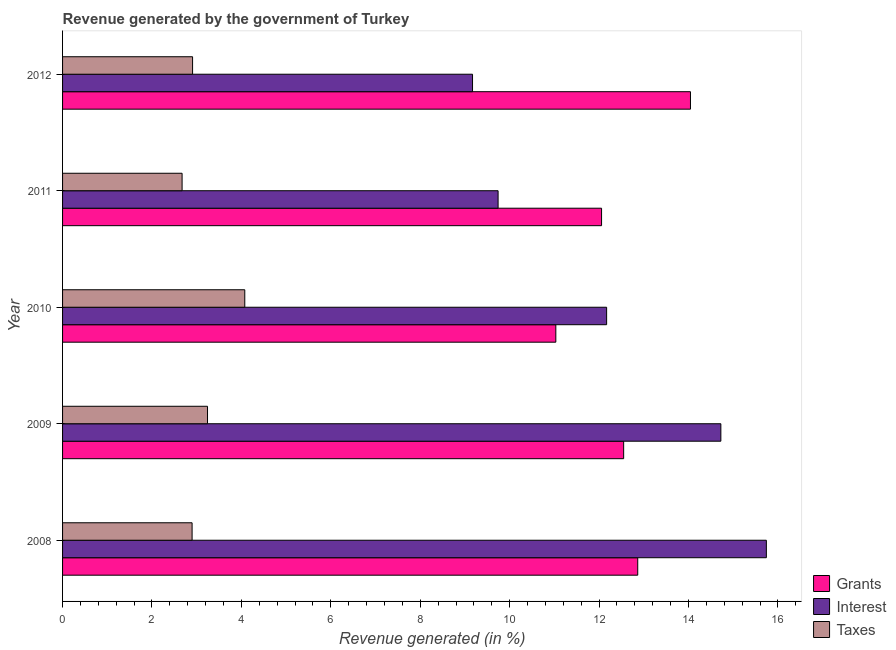How many different coloured bars are there?
Keep it short and to the point. 3. How many groups of bars are there?
Offer a terse response. 5. Are the number of bars per tick equal to the number of legend labels?
Give a very brief answer. Yes. Are the number of bars on each tick of the Y-axis equal?
Your answer should be very brief. Yes. How many bars are there on the 2nd tick from the top?
Make the answer very short. 3. How many bars are there on the 5th tick from the bottom?
Your response must be concise. 3. What is the percentage of revenue generated by grants in 2008?
Your answer should be compact. 12.86. Across all years, what is the maximum percentage of revenue generated by grants?
Offer a terse response. 14.04. Across all years, what is the minimum percentage of revenue generated by grants?
Your answer should be compact. 11.03. What is the total percentage of revenue generated by taxes in the graph?
Provide a succinct answer. 15.8. What is the difference between the percentage of revenue generated by interest in 2008 and that in 2010?
Ensure brevity in your answer.  3.57. What is the difference between the percentage of revenue generated by taxes in 2010 and the percentage of revenue generated by grants in 2012?
Offer a terse response. -9.97. What is the average percentage of revenue generated by grants per year?
Offer a terse response. 12.51. In the year 2010, what is the difference between the percentage of revenue generated by grants and percentage of revenue generated by interest?
Your response must be concise. -1.14. In how many years, is the percentage of revenue generated by taxes greater than 8.4 %?
Keep it short and to the point. 0. What is the ratio of the percentage of revenue generated by grants in 2009 to that in 2011?
Provide a succinct answer. 1.04. Is the percentage of revenue generated by taxes in 2008 less than that in 2012?
Your answer should be compact. Yes. What is the difference between the highest and the second highest percentage of revenue generated by interest?
Your answer should be compact. 1.02. What is the difference between the highest and the lowest percentage of revenue generated by grants?
Offer a terse response. 3.01. In how many years, is the percentage of revenue generated by interest greater than the average percentage of revenue generated by interest taken over all years?
Make the answer very short. 2. Is the sum of the percentage of revenue generated by taxes in 2008 and 2010 greater than the maximum percentage of revenue generated by interest across all years?
Make the answer very short. No. What does the 2nd bar from the top in 2012 represents?
Offer a terse response. Interest. What does the 2nd bar from the bottom in 2011 represents?
Provide a succinct answer. Interest. Is it the case that in every year, the sum of the percentage of revenue generated by grants and percentage of revenue generated by interest is greater than the percentage of revenue generated by taxes?
Provide a succinct answer. Yes. How many bars are there?
Your answer should be very brief. 15. How many years are there in the graph?
Your answer should be compact. 5. Are the values on the major ticks of X-axis written in scientific E-notation?
Your answer should be compact. No. Does the graph contain grids?
Your answer should be compact. No. Where does the legend appear in the graph?
Offer a very short reply. Bottom right. How many legend labels are there?
Your response must be concise. 3. What is the title of the graph?
Your answer should be compact. Revenue generated by the government of Turkey. Does "Food" appear as one of the legend labels in the graph?
Ensure brevity in your answer.  No. What is the label or title of the X-axis?
Offer a terse response. Revenue generated (in %). What is the Revenue generated (in %) of Grants in 2008?
Make the answer very short. 12.86. What is the Revenue generated (in %) in Interest in 2008?
Give a very brief answer. 15.74. What is the Revenue generated (in %) of Taxes in 2008?
Your answer should be very brief. 2.9. What is the Revenue generated (in %) in Grants in 2009?
Give a very brief answer. 12.55. What is the Revenue generated (in %) of Interest in 2009?
Offer a very short reply. 14.72. What is the Revenue generated (in %) of Taxes in 2009?
Your response must be concise. 3.24. What is the Revenue generated (in %) in Grants in 2010?
Your answer should be very brief. 11.03. What is the Revenue generated (in %) in Interest in 2010?
Your answer should be very brief. 12.17. What is the Revenue generated (in %) in Taxes in 2010?
Make the answer very short. 4.08. What is the Revenue generated (in %) of Grants in 2011?
Keep it short and to the point. 12.05. What is the Revenue generated (in %) in Interest in 2011?
Keep it short and to the point. 9.74. What is the Revenue generated (in %) in Taxes in 2011?
Make the answer very short. 2.67. What is the Revenue generated (in %) in Grants in 2012?
Provide a succinct answer. 14.04. What is the Revenue generated (in %) in Interest in 2012?
Provide a short and direct response. 9.17. What is the Revenue generated (in %) of Taxes in 2012?
Offer a very short reply. 2.91. Across all years, what is the maximum Revenue generated (in %) in Grants?
Provide a succinct answer. 14.04. Across all years, what is the maximum Revenue generated (in %) of Interest?
Provide a short and direct response. 15.74. Across all years, what is the maximum Revenue generated (in %) in Taxes?
Your answer should be very brief. 4.08. Across all years, what is the minimum Revenue generated (in %) in Grants?
Offer a terse response. 11.03. Across all years, what is the minimum Revenue generated (in %) of Interest?
Make the answer very short. 9.17. Across all years, what is the minimum Revenue generated (in %) in Taxes?
Your response must be concise. 2.67. What is the total Revenue generated (in %) of Grants in the graph?
Keep it short and to the point. 62.54. What is the total Revenue generated (in %) in Interest in the graph?
Provide a succinct answer. 61.54. What is the total Revenue generated (in %) in Taxes in the graph?
Your answer should be very brief. 15.8. What is the difference between the Revenue generated (in %) of Grants in 2008 and that in 2009?
Give a very brief answer. 0.32. What is the difference between the Revenue generated (in %) of Interest in 2008 and that in 2009?
Keep it short and to the point. 1.02. What is the difference between the Revenue generated (in %) of Taxes in 2008 and that in 2009?
Ensure brevity in your answer.  -0.34. What is the difference between the Revenue generated (in %) of Grants in 2008 and that in 2010?
Your response must be concise. 1.83. What is the difference between the Revenue generated (in %) of Interest in 2008 and that in 2010?
Give a very brief answer. 3.57. What is the difference between the Revenue generated (in %) in Taxes in 2008 and that in 2010?
Your answer should be very brief. -1.18. What is the difference between the Revenue generated (in %) of Grants in 2008 and that in 2011?
Give a very brief answer. 0.81. What is the difference between the Revenue generated (in %) in Interest in 2008 and that in 2011?
Give a very brief answer. 6. What is the difference between the Revenue generated (in %) of Taxes in 2008 and that in 2011?
Offer a terse response. 0.22. What is the difference between the Revenue generated (in %) in Grants in 2008 and that in 2012?
Provide a short and direct response. -1.18. What is the difference between the Revenue generated (in %) in Interest in 2008 and that in 2012?
Your answer should be compact. 6.57. What is the difference between the Revenue generated (in %) of Taxes in 2008 and that in 2012?
Make the answer very short. -0.01. What is the difference between the Revenue generated (in %) of Grants in 2009 and that in 2010?
Your response must be concise. 1.52. What is the difference between the Revenue generated (in %) of Interest in 2009 and that in 2010?
Your answer should be compact. 2.56. What is the difference between the Revenue generated (in %) of Taxes in 2009 and that in 2010?
Your answer should be compact. -0.83. What is the difference between the Revenue generated (in %) in Grants in 2009 and that in 2011?
Ensure brevity in your answer.  0.49. What is the difference between the Revenue generated (in %) of Interest in 2009 and that in 2011?
Offer a very short reply. 4.98. What is the difference between the Revenue generated (in %) in Taxes in 2009 and that in 2011?
Provide a short and direct response. 0.57. What is the difference between the Revenue generated (in %) of Grants in 2009 and that in 2012?
Make the answer very short. -1.49. What is the difference between the Revenue generated (in %) in Interest in 2009 and that in 2012?
Make the answer very short. 5.55. What is the difference between the Revenue generated (in %) of Taxes in 2009 and that in 2012?
Make the answer very short. 0.33. What is the difference between the Revenue generated (in %) in Grants in 2010 and that in 2011?
Offer a terse response. -1.02. What is the difference between the Revenue generated (in %) of Interest in 2010 and that in 2011?
Your answer should be very brief. 2.43. What is the difference between the Revenue generated (in %) in Taxes in 2010 and that in 2011?
Your answer should be very brief. 1.4. What is the difference between the Revenue generated (in %) of Grants in 2010 and that in 2012?
Offer a terse response. -3.01. What is the difference between the Revenue generated (in %) of Interest in 2010 and that in 2012?
Make the answer very short. 3. What is the difference between the Revenue generated (in %) in Taxes in 2010 and that in 2012?
Offer a terse response. 1.17. What is the difference between the Revenue generated (in %) in Grants in 2011 and that in 2012?
Keep it short and to the point. -1.99. What is the difference between the Revenue generated (in %) in Interest in 2011 and that in 2012?
Ensure brevity in your answer.  0.57. What is the difference between the Revenue generated (in %) of Taxes in 2011 and that in 2012?
Keep it short and to the point. -0.23. What is the difference between the Revenue generated (in %) of Grants in 2008 and the Revenue generated (in %) of Interest in 2009?
Your response must be concise. -1.86. What is the difference between the Revenue generated (in %) in Grants in 2008 and the Revenue generated (in %) in Taxes in 2009?
Your answer should be very brief. 9.62. What is the difference between the Revenue generated (in %) of Interest in 2008 and the Revenue generated (in %) of Taxes in 2009?
Keep it short and to the point. 12.5. What is the difference between the Revenue generated (in %) of Grants in 2008 and the Revenue generated (in %) of Interest in 2010?
Make the answer very short. 0.7. What is the difference between the Revenue generated (in %) in Grants in 2008 and the Revenue generated (in %) in Taxes in 2010?
Offer a very short reply. 8.79. What is the difference between the Revenue generated (in %) in Interest in 2008 and the Revenue generated (in %) in Taxes in 2010?
Offer a very short reply. 11.67. What is the difference between the Revenue generated (in %) in Grants in 2008 and the Revenue generated (in %) in Interest in 2011?
Ensure brevity in your answer.  3.12. What is the difference between the Revenue generated (in %) of Grants in 2008 and the Revenue generated (in %) of Taxes in 2011?
Provide a succinct answer. 10.19. What is the difference between the Revenue generated (in %) in Interest in 2008 and the Revenue generated (in %) in Taxes in 2011?
Your answer should be compact. 13.07. What is the difference between the Revenue generated (in %) in Grants in 2008 and the Revenue generated (in %) in Interest in 2012?
Offer a very short reply. 3.69. What is the difference between the Revenue generated (in %) in Grants in 2008 and the Revenue generated (in %) in Taxes in 2012?
Your answer should be compact. 9.96. What is the difference between the Revenue generated (in %) of Interest in 2008 and the Revenue generated (in %) of Taxes in 2012?
Your response must be concise. 12.83. What is the difference between the Revenue generated (in %) of Grants in 2009 and the Revenue generated (in %) of Interest in 2010?
Offer a terse response. 0.38. What is the difference between the Revenue generated (in %) in Grants in 2009 and the Revenue generated (in %) in Taxes in 2010?
Your response must be concise. 8.47. What is the difference between the Revenue generated (in %) in Interest in 2009 and the Revenue generated (in %) in Taxes in 2010?
Your response must be concise. 10.65. What is the difference between the Revenue generated (in %) in Grants in 2009 and the Revenue generated (in %) in Interest in 2011?
Your answer should be compact. 2.81. What is the difference between the Revenue generated (in %) in Grants in 2009 and the Revenue generated (in %) in Taxes in 2011?
Your answer should be very brief. 9.88. What is the difference between the Revenue generated (in %) of Interest in 2009 and the Revenue generated (in %) of Taxes in 2011?
Provide a short and direct response. 12.05. What is the difference between the Revenue generated (in %) of Grants in 2009 and the Revenue generated (in %) of Interest in 2012?
Provide a succinct answer. 3.38. What is the difference between the Revenue generated (in %) in Grants in 2009 and the Revenue generated (in %) in Taxes in 2012?
Ensure brevity in your answer.  9.64. What is the difference between the Revenue generated (in %) in Interest in 2009 and the Revenue generated (in %) in Taxes in 2012?
Your answer should be very brief. 11.82. What is the difference between the Revenue generated (in %) in Grants in 2010 and the Revenue generated (in %) in Interest in 2011?
Make the answer very short. 1.29. What is the difference between the Revenue generated (in %) of Grants in 2010 and the Revenue generated (in %) of Taxes in 2011?
Provide a succinct answer. 8.36. What is the difference between the Revenue generated (in %) in Interest in 2010 and the Revenue generated (in %) in Taxes in 2011?
Offer a very short reply. 9.5. What is the difference between the Revenue generated (in %) in Grants in 2010 and the Revenue generated (in %) in Interest in 2012?
Your answer should be very brief. 1.86. What is the difference between the Revenue generated (in %) in Grants in 2010 and the Revenue generated (in %) in Taxes in 2012?
Make the answer very short. 8.12. What is the difference between the Revenue generated (in %) of Interest in 2010 and the Revenue generated (in %) of Taxes in 2012?
Make the answer very short. 9.26. What is the difference between the Revenue generated (in %) in Grants in 2011 and the Revenue generated (in %) in Interest in 2012?
Your answer should be compact. 2.89. What is the difference between the Revenue generated (in %) in Grants in 2011 and the Revenue generated (in %) in Taxes in 2012?
Offer a very short reply. 9.15. What is the difference between the Revenue generated (in %) of Interest in 2011 and the Revenue generated (in %) of Taxes in 2012?
Keep it short and to the point. 6.83. What is the average Revenue generated (in %) of Grants per year?
Keep it short and to the point. 12.51. What is the average Revenue generated (in %) of Interest per year?
Your answer should be very brief. 12.31. What is the average Revenue generated (in %) in Taxes per year?
Give a very brief answer. 3.16. In the year 2008, what is the difference between the Revenue generated (in %) in Grants and Revenue generated (in %) in Interest?
Keep it short and to the point. -2.88. In the year 2008, what is the difference between the Revenue generated (in %) in Grants and Revenue generated (in %) in Taxes?
Offer a terse response. 9.97. In the year 2008, what is the difference between the Revenue generated (in %) in Interest and Revenue generated (in %) in Taxes?
Provide a succinct answer. 12.84. In the year 2009, what is the difference between the Revenue generated (in %) in Grants and Revenue generated (in %) in Interest?
Your answer should be compact. -2.17. In the year 2009, what is the difference between the Revenue generated (in %) in Grants and Revenue generated (in %) in Taxes?
Ensure brevity in your answer.  9.31. In the year 2009, what is the difference between the Revenue generated (in %) of Interest and Revenue generated (in %) of Taxes?
Your answer should be compact. 11.48. In the year 2010, what is the difference between the Revenue generated (in %) in Grants and Revenue generated (in %) in Interest?
Offer a very short reply. -1.14. In the year 2010, what is the difference between the Revenue generated (in %) in Grants and Revenue generated (in %) in Taxes?
Your response must be concise. 6.96. In the year 2010, what is the difference between the Revenue generated (in %) of Interest and Revenue generated (in %) of Taxes?
Offer a terse response. 8.09. In the year 2011, what is the difference between the Revenue generated (in %) of Grants and Revenue generated (in %) of Interest?
Your response must be concise. 2.31. In the year 2011, what is the difference between the Revenue generated (in %) of Grants and Revenue generated (in %) of Taxes?
Your answer should be very brief. 9.38. In the year 2011, what is the difference between the Revenue generated (in %) in Interest and Revenue generated (in %) in Taxes?
Provide a succinct answer. 7.07. In the year 2012, what is the difference between the Revenue generated (in %) in Grants and Revenue generated (in %) in Interest?
Make the answer very short. 4.87. In the year 2012, what is the difference between the Revenue generated (in %) in Grants and Revenue generated (in %) in Taxes?
Offer a very short reply. 11.14. In the year 2012, what is the difference between the Revenue generated (in %) of Interest and Revenue generated (in %) of Taxes?
Keep it short and to the point. 6.26. What is the ratio of the Revenue generated (in %) in Grants in 2008 to that in 2009?
Ensure brevity in your answer.  1.03. What is the ratio of the Revenue generated (in %) in Interest in 2008 to that in 2009?
Your answer should be compact. 1.07. What is the ratio of the Revenue generated (in %) in Taxes in 2008 to that in 2009?
Make the answer very short. 0.89. What is the ratio of the Revenue generated (in %) in Grants in 2008 to that in 2010?
Offer a terse response. 1.17. What is the ratio of the Revenue generated (in %) of Interest in 2008 to that in 2010?
Offer a terse response. 1.29. What is the ratio of the Revenue generated (in %) of Taxes in 2008 to that in 2010?
Your response must be concise. 0.71. What is the ratio of the Revenue generated (in %) of Grants in 2008 to that in 2011?
Offer a very short reply. 1.07. What is the ratio of the Revenue generated (in %) of Interest in 2008 to that in 2011?
Provide a short and direct response. 1.62. What is the ratio of the Revenue generated (in %) of Taxes in 2008 to that in 2011?
Provide a succinct answer. 1.08. What is the ratio of the Revenue generated (in %) in Grants in 2008 to that in 2012?
Give a very brief answer. 0.92. What is the ratio of the Revenue generated (in %) of Interest in 2008 to that in 2012?
Your response must be concise. 1.72. What is the ratio of the Revenue generated (in %) in Taxes in 2008 to that in 2012?
Your response must be concise. 1. What is the ratio of the Revenue generated (in %) of Grants in 2009 to that in 2010?
Your response must be concise. 1.14. What is the ratio of the Revenue generated (in %) of Interest in 2009 to that in 2010?
Your answer should be very brief. 1.21. What is the ratio of the Revenue generated (in %) of Taxes in 2009 to that in 2010?
Provide a succinct answer. 0.8. What is the ratio of the Revenue generated (in %) in Grants in 2009 to that in 2011?
Your answer should be compact. 1.04. What is the ratio of the Revenue generated (in %) of Interest in 2009 to that in 2011?
Provide a succinct answer. 1.51. What is the ratio of the Revenue generated (in %) of Taxes in 2009 to that in 2011?
Your answer should be compact. 1.21. What is the ratio of the Revenue generated (in %) of Grants in 2009 to that in 2012?
Offer a very short reply. 0.89. What is the ratio of the Revenue generated (in %) of Interest in 2009 to that in 2012?
Give a very brief answer. 1.61. What is the ratio of the Revenue generated (in %) in Taxes in 2009 to that in 2012?
Your answer should be compact. 1.11. What is the ratio of the Revenue generated (in %) of Grants in 2010 to that in 2011?
Your answer should be very brief. 0.92. What is the ratio of the Revenue generated (in %) of Interest in 2010 to that in 2011?
Provide a short and direct response. 1.25. What is the ratio of the Revenue generated (in %) of Taxes in 2010 to that in 2011?
Ensure brevity in your answer.  1.52. What is the ratio of the Revenue generated (in %) in Grants in 2010 to that in 2012?
Provide a short and direct response. 0.79. What is the ratio of the Revenue generated (in %) in Interest in 2010 to that in 2012?
Provide a short and direct response. 1.33. What is the ratio of the Revenue generated (in %) of Taxes in 2010 to that in 2012?
Offer a very short reply. 1.4. What is the ratio of the Revenue generated (in %) in Grants in 2011 to that in 2012?
Provide a short and direct response. 0.86. What is the ratio of the Revenue generated (in %) of Interest in 2011 to that in 2012?
Your response must be concise. 1.06. What is the ratio of the Revenue generated (in %) in Taxes in 2011 to that in 2012?
Offer a terse response. 0.92. What is the difference between the highest and the second highest Revenue generated (in %) in Grants?
Provide a short and direct response. 1.18. What is the difference between the highest and the second highest Revenue generated (in %) in Interest?
Make the answer very short. 1.02. What is the difference between the highest and the second highest Revenue generated (in %) of Taxes?
Provide a short and direct response. 0.83. What is the difference between the highest and the lowest Revenue generated (in %) of Grants?
Your response must be concise. 3.01. What is the difference between the highest and the lowest Revenue generated (in %) in Interest?
Make the answer very short. 6.57. What is the difference between the highest and the lowest Revenue generated (in %) in Taxes?
Provide a succinct answer. 1.4. 